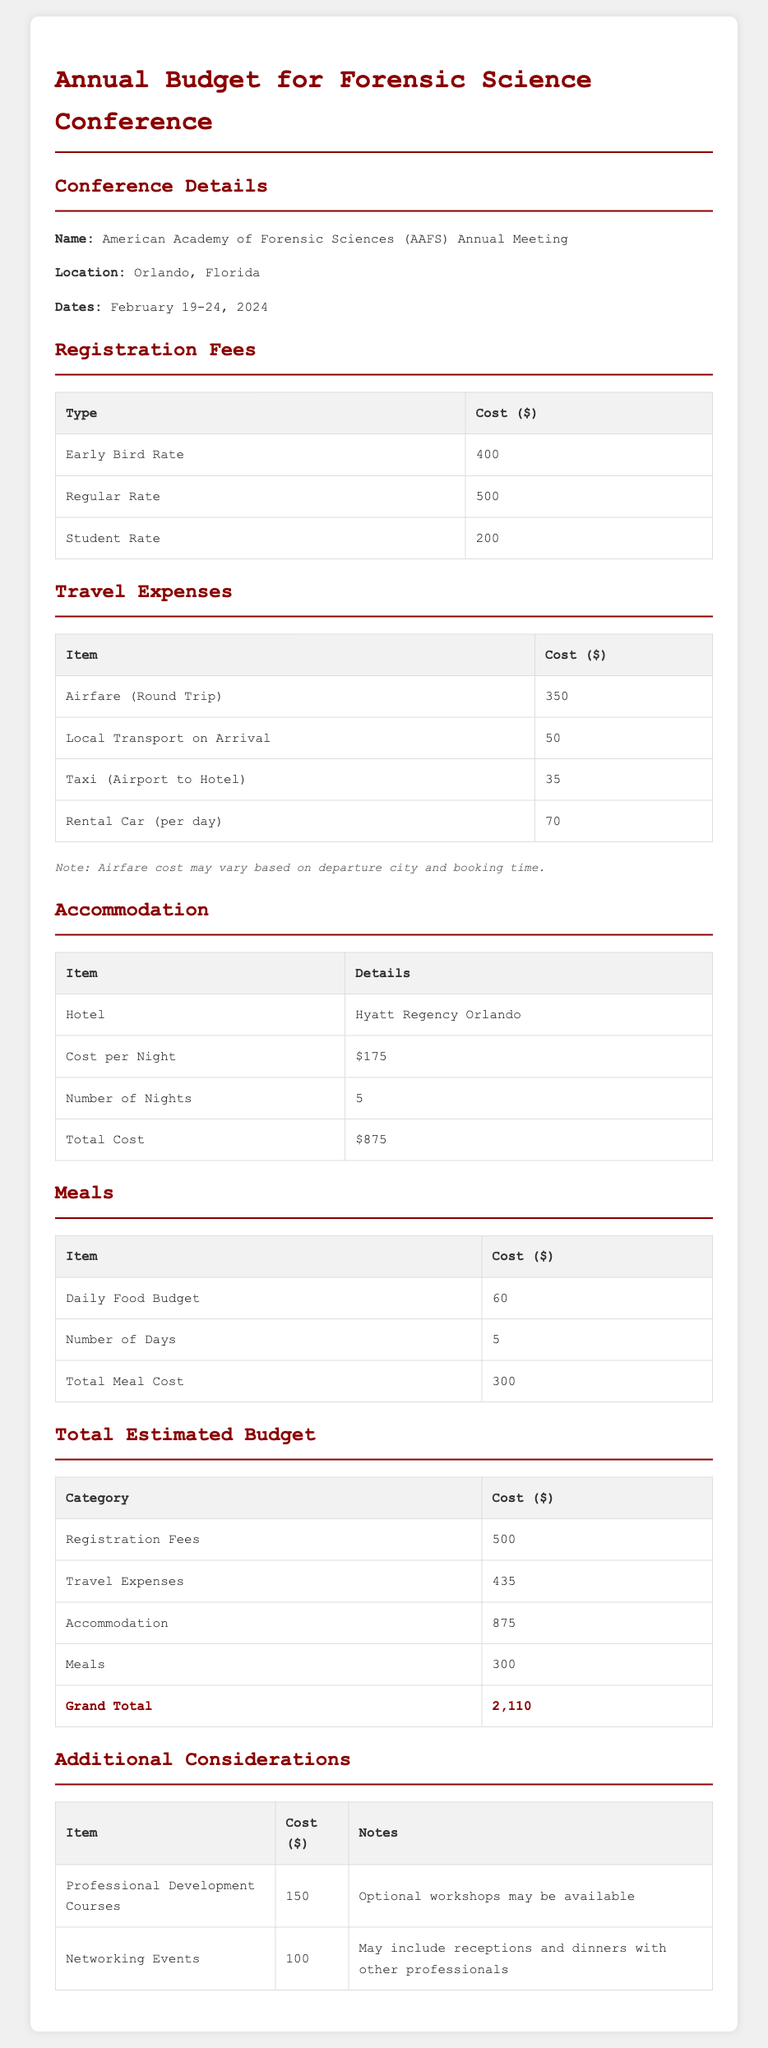What is the location of the conference? The document states that the conference will take place in Orlando, Florida.
Answer: Orlando, Florida What is the early bird registration fee? The early bird registration fee is listed as $400 in the registration fees table.
Answer: 400 How much is the total cost for meals? The total cost for meals is given as $300 in the total estimated budget section.
Answer: 300 What is the number of nights for accommodation? The number of nights mentioned for accommodation is 5 according to the accommodation section.
Answer: 5 What is the grand total estimated budget? The grand total estimated budget, summarizing all costs, is $2,110.
Answer: 2,110 What are the travel expenses in total? The document indicates that the total travel expenses amount to $435 in the total estimated budget section.
Answer: 435 What is the cost per night for the hotel? The cost per night for the hotel listed in the accommodation section is $175.
Answer: 175 What is the cost for professional development courses? The document notes the cost for professional development courses is $150 in the additional considerations table.
Answer: 150 What are the dates of the conference? The document specifies that the conference dates are February 19-24, 2024.
Answer: February 19-24, 2024 